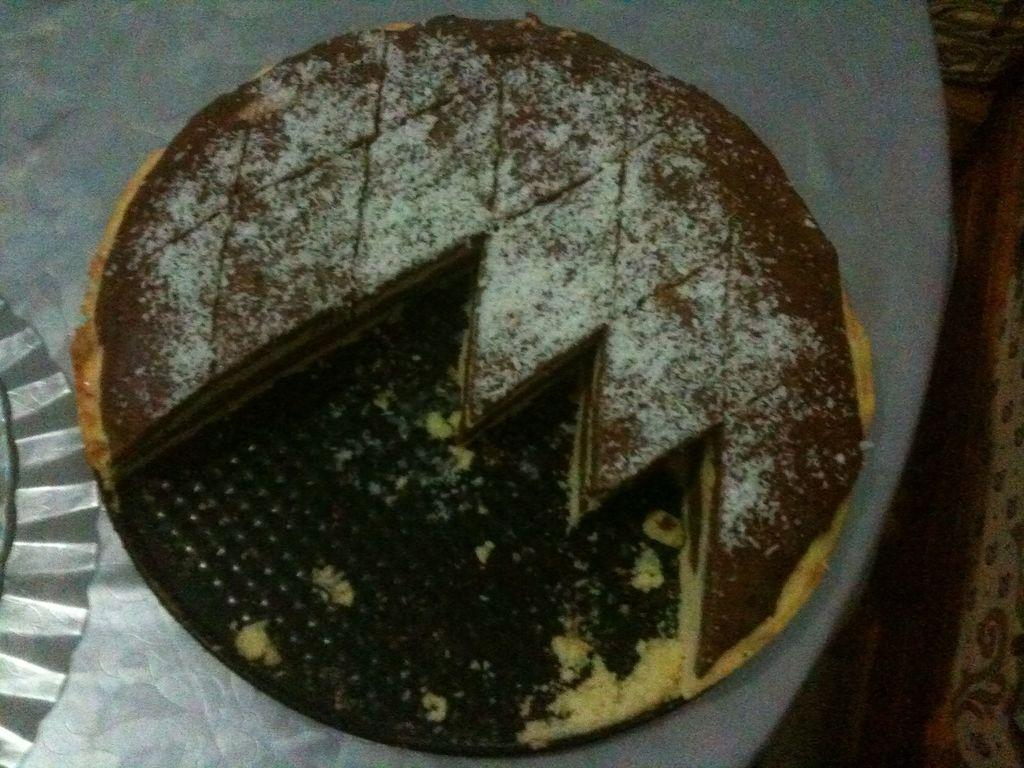What is the main subject of the image? There is a cake in the image. Where is the cake located? The cake is on a table. What else can be seen on the left side of the image? There is a plastic plate on the left side of the image. What can be seen on the right side of the image? The floor is visible on the right side of the image. How does the fog affect the cake in the image? There is no fog present in the image, so it does not affect the cake. What type of wing is attached to the cake in the image? There are no wings attached to the cake in the image. 